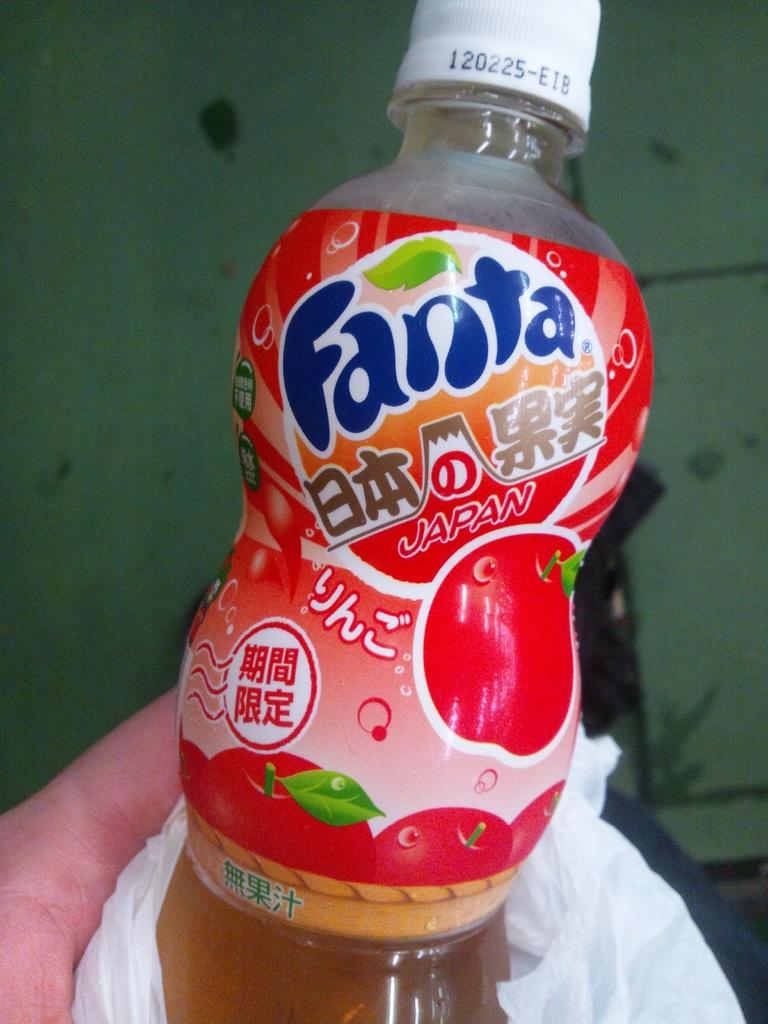<image>
Summarize the visual content of the image. A small bottle of Fanta is being being held. 